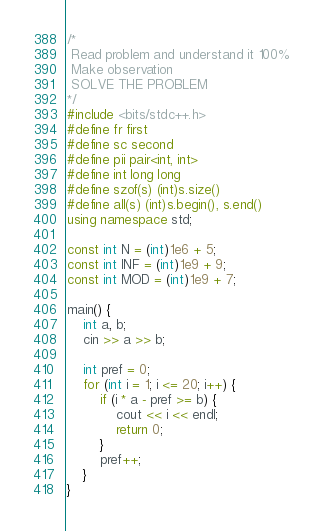Convert code to text. <code><loc_0><loc_0><loc_500><loc_500><_C++_>/*
 Read problem and understand it 100%
 Make observation
 SOLVE THE PROBLEM
*/
#include <bits/stdc++.h>
#define fr first
#define sc second
#define pii pair<int, int>
#define int long long
#define szof(s) (int)s.size()
#define all(s) (int)s.begin(), s.end()
using namespace std;
 
const int N = (int)1e6 + 5;
const int INF = (int)1e9 + 9;
const int MOD = (int)1e9 + 7;
 
main() {
	int a, b;
	cin >> a >> b;
	
	int pref = 0;
	for (int i = 1; i <= 20; i++) {
		if (i * a - pref >= b) {
			cout << i << endl;
			return 0;
		}
		pref++;
	}
}
</code> 